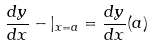Convert formula to latex. <formula><loc_0><loc_0><loc_500><loc_500>\frac { d y } { d x } - | _ { x = a } = \frac { d y } { d x } ( a )</formula> 